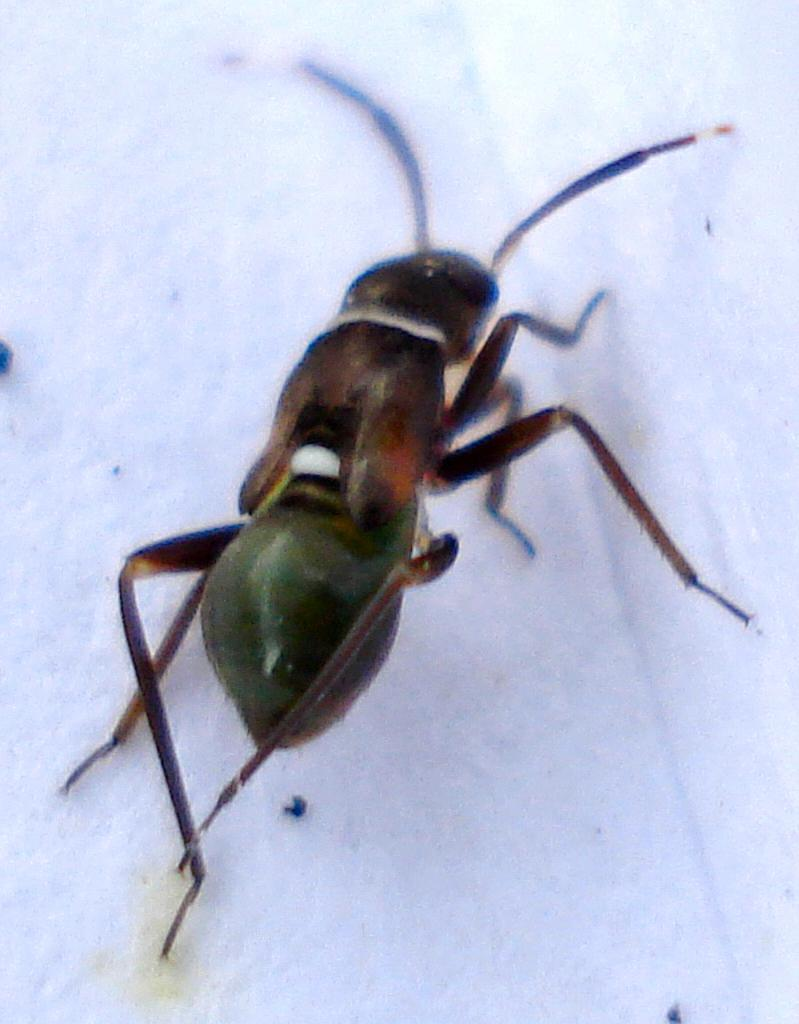What is the main subject of the image? There is an ant in the center of the image. How many trees are visible in the image? There are no trees visible in the image; it only features an ant in the center. What type of cake is being eaten by the ghost in the image? There is no cake or ghost present in the image; it only features an ant. 